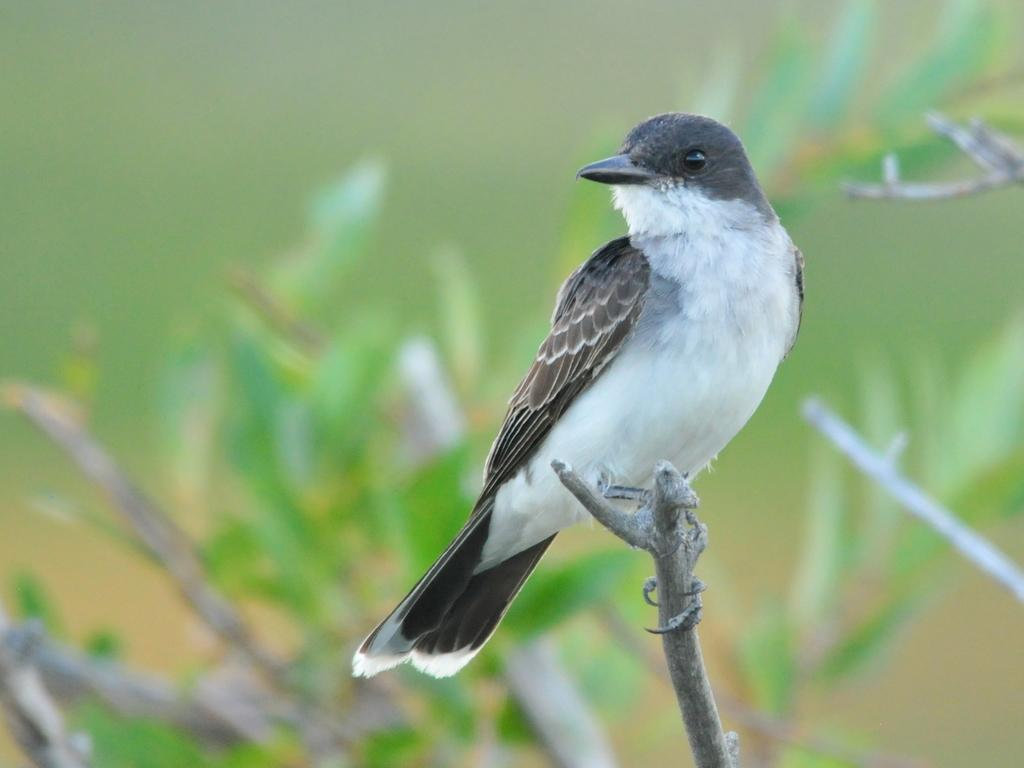What type of animal can be seen in the image? There is a bird in the image. How is the bird positioned in the image? The bird is on a stick. Can you describe the background of the image? The background of the image is blurred. What type of wound can be seen on the bird's wing in the image? There is no wound visible on the bird's wing in the image. 